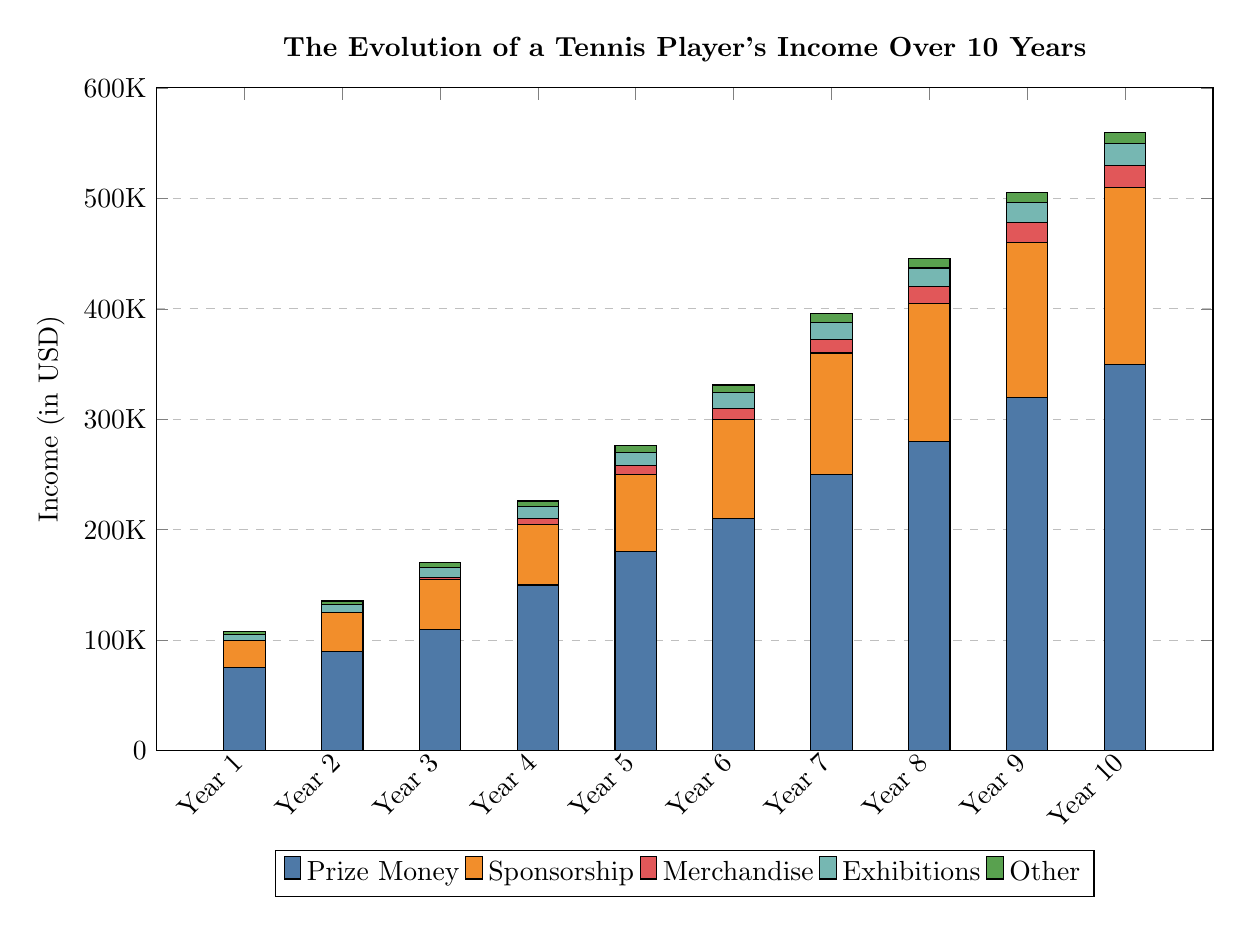What was the total income in Year 10? In Year 10, the total income is obtained by summing all components displayed in the stacked bar for that year: Prize Money (350,000) + Sponsorship (160,000) + Merchandise (20,000) + Exhibitions (20,000) + Other (10,000) = 560,000.
Answer: 560,000 Which source of income had the highest value in Year 6? In Year 6, the stacked bar shows that Prize Money is the highest source of income at 210,000, compared to other sources: Sponsorship (90,000), Merchandise (10,000), Exhibitions (14,000), and Other (7,000).
Answer: Prize Money How much did sponsorship income increase from Year 1 to Year 5? The increase in sponsorship income from Year 1 (25,000) to Year 5 (70,000) is calculated by subtracting the Year 1 figure from Year 5: 70,000 - 25,000 = 45,000.
Answer: 45,000 What is the total income from merchandise by Year 10? The total income from merchandise by Year 10 is 20,000, as shown directly in the stacked bar for that year, which represents its cumulative income from previous years as well.
Answer: 20,000 In which year did the income from exhibitions exceed 15,000? The income from exhibitions first exceeded 15,000 in Year 8, where it is illustrated to be 17,000, while in Year 7, it is shown as 16,000, and it is lower in Years 1 to 6.
Answer: Year 8 How much did the total prize money grow over the 10 years? To find the growth of total prize money over the 10 years, we subtract the value in Year 1 (75,000) from the value in Year 10 (350,000): 350,000 - 75,000 = 275,000.
Answer: 275,000 What percentage of the total income in Year 9 came from other sources? In Year 9, the total income is 490,000 and the income from other sources is shown as 9,000. To find the percentage, we calculate: (9,000 / 490,000) * 100 ≈ 1.84%.
Answer: Approximately 1.84% What is the total income across all years for sponsorship? To find the total income from sponsorship across all years, we sum the yearly sponsorship incomes: 25,000 + 35,000 + 45,000 + 55,000 + 70,000 + 90,000 + 110,000 + 125,000 + 140,000 + 160,000 = 1,050,000.
Answer: 1,050,000 How does the income from 'Other' sources change in the last three years? In the last three years, the income from 'Other' sources shows a consistent increase: Year 8 is 8,500, Year 9 is 9,000, and Year 10 is 10,000, indicating a growth trend in that category.
Answer: Increasing 